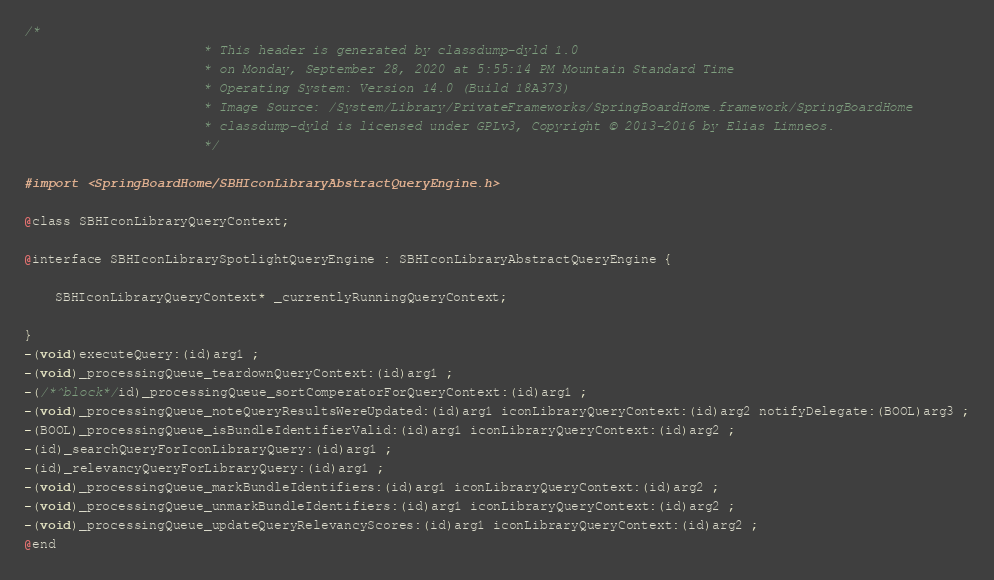Convert code to text. <code><loc_0><loc_0><loc_500><loc_500><_C_>/*
                       * This header is generated by classdump-dyld 1.0
                       * on Monday, September 28, 2020 at 5:55:14 PM Mountain Standard Time
                       * Operating System: Version 14.0 (Build 18A373)
                       * Image Source: /System/Library/PrivateFrameworks/SpringBoardHome.framework/SpringBoardHome
                       * classdump-dyld is licensed under GPLv3, Copyright © 2013-2016 by Elias Limneos.
                       */

#import <SpringBoardHome/SBHIconLibraryAbstractQueryEngine.h>

@class SBHIconLibraryQueryContext;

@interface SBHIconLibrarySpotlightQueryEngine : SBHIconLibraryAbstractQueryEngine {

	SBHIconLibraryQueryContext* _currentlyRunningQueryContext;

}
-(void)executeQuery:(id)arg1 ;
-(void)_processingQueue_teardownQueryContext:(id)arg1 ;
-(/*^block*/id)_processingQueue_sortComperatorForQueryContext:(id)arg1 ;
-(void)_processingQueue_noteQueryResultsWereUpdated:(id)arg1 iconLibraryQueryContext:(id)arg2 notifyDelegate:(BOOL)arg3 ;
-(BOOL)_processingQueue_isBundleIdentifierValid:(id)arg1 iconLibraryQueryContext:(id)arg2 ;
-(id)_searchQueryForIconLibraryQuery:(id)arg1 ;
-(id)_relevancyQueryForLibraryQuery:(id)arg1 ;
-(void)_processingQueue_markBundleIdentifiers:(id)arg1 iconLibraryQueryContext:(id)arg2 ;
-(void)_processingQueue_unmarkBundleIdentifiers:(id)arg1 iconLibraryQueryContext:(id)arg2 ;
-(void)_processingQueue_updateQueryRelevancyScores:(id)arg1 iconLibraryQueryContext:(id)arg2 ;
@end

</code> 